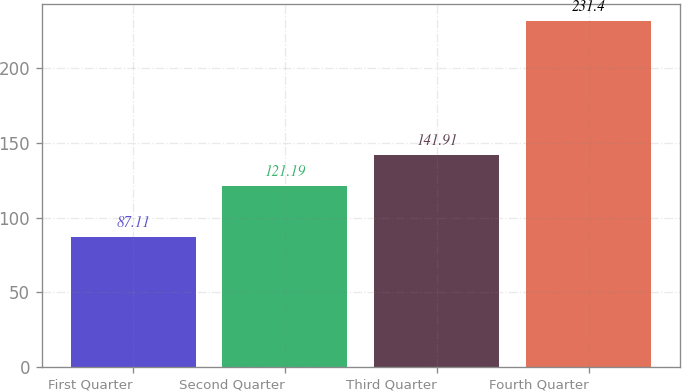<chart> <loc_0><loc_0><loc_500><loc_500><bar_chart><fcel>First Quarter<fcel>Second Quarter<fcel>Third Quarter<fcel>Fourth Quarter<nl><fcel>87.11<fcel>121.19<fcel>141.91<fcel>231.4<nl></chart> 